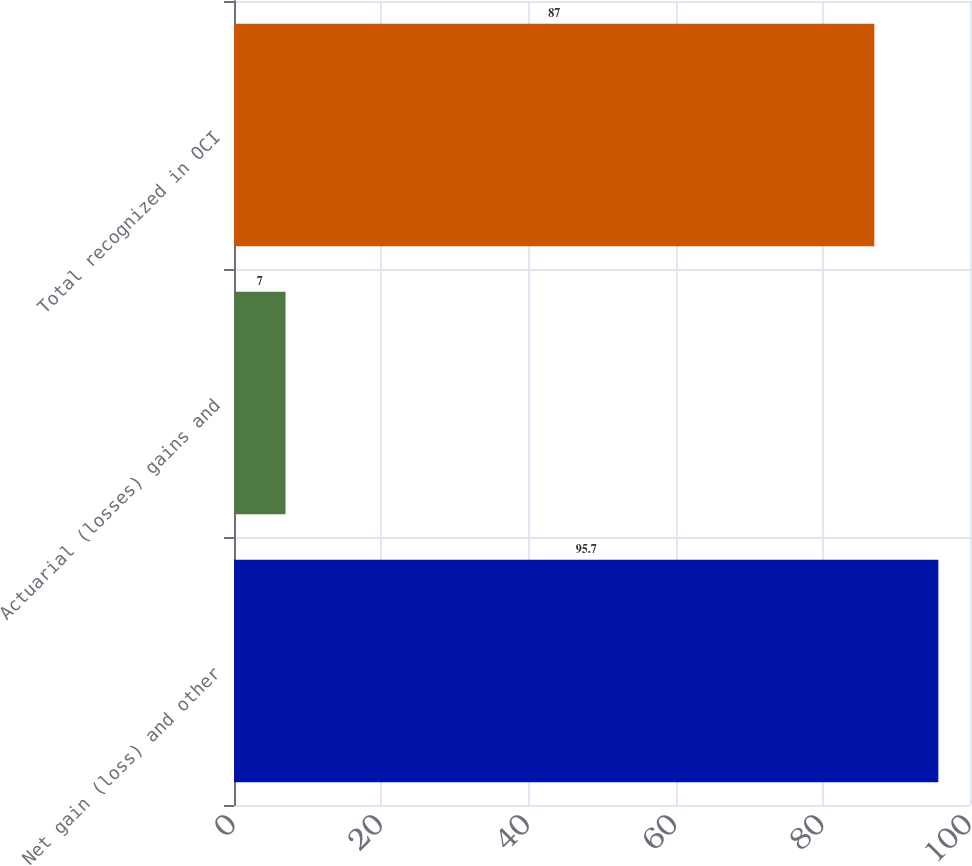Convert chart to OTSL. <chart><loc_0><loc_0><loc_500><loc_500><bar_chart><fcel>Net gain (loss) and other<fcel>Actuarial (losses) gains and<fcel>Total recognized in OCI<nl><fcel>95.7<fcel>7<fcel>87<nl></chart> 